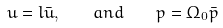Convert formula to latex. <formula><loc_0><loc_0><loc_500><loc_500>u = l \bar { u } , \quad a n d \quad p = \Omega _ { 0 } \bar { p }</formula> 